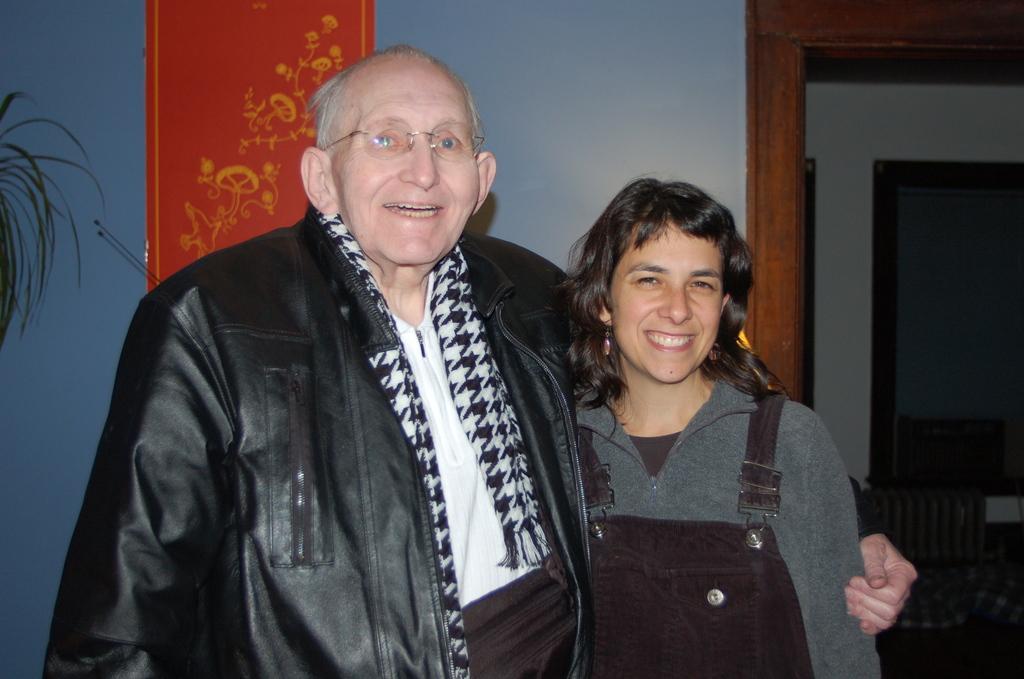Describe this image in one or two sentences. In the center of the image there is a man wearing a jacket and there is a woman. In the background of the image there is a wall. There is a poster. To the right side of the image there is a door. To the left side of the image there are leaves of a plant. 